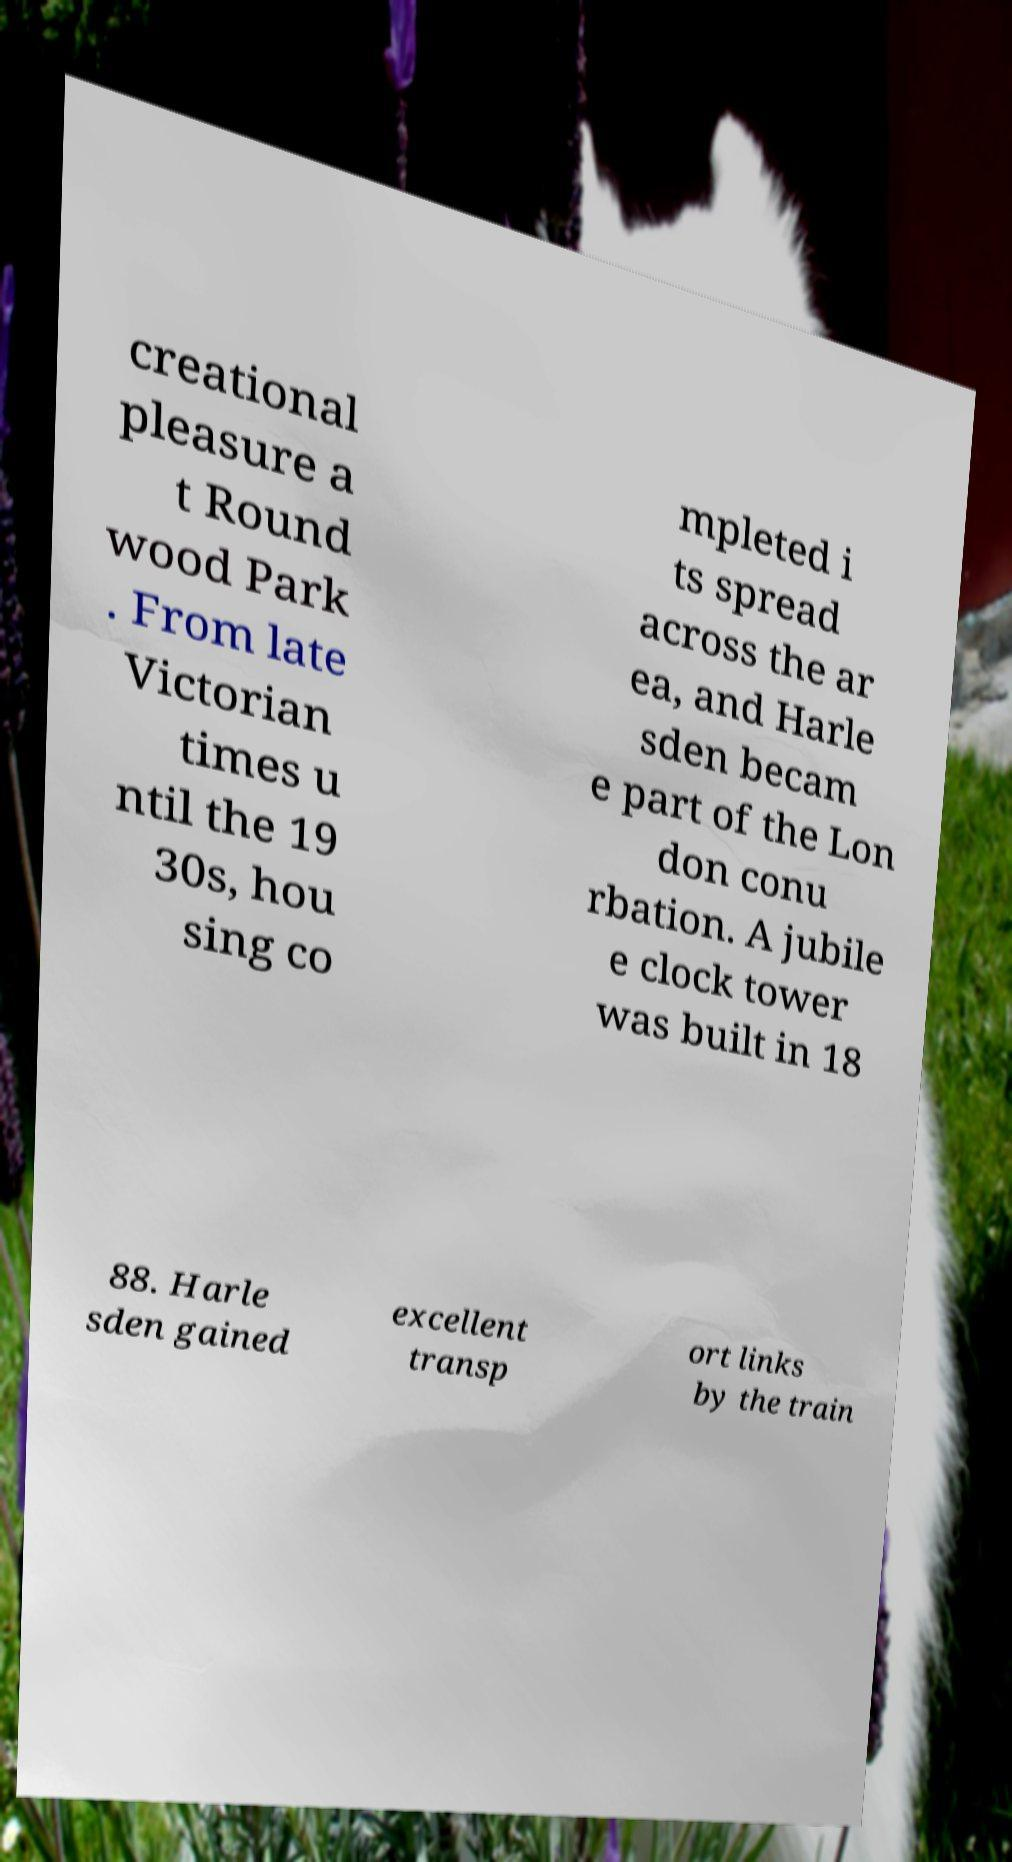Could you extract and type out the text from this image? creational pleasure a t Round wood Park . From late Victorian times u ntil the 19 30s, hou sing co mpleted i ts spread across the ar ea, and Harle sden becam e part of the Lon don conu rbation. A jubile e clock tower was built in 18 88. Harle sden gained excellent transp ort links by the train 